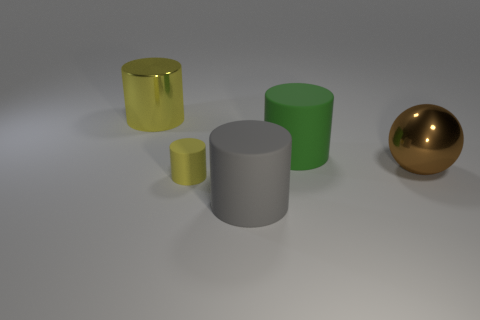There is a thing that is the same color as the metallic cylinder; what is its size?
Make the answer very short. Small. There is a yellow rubber thing that is the same shape as the big gray rubber thing; what size is it?
Your response must be concise. Small. Is there anything else that has the same size as the yellow matte object?
Make the answer very short. No. Are there more big rubber things that are in front of the green rubber cylinder than large gray things that are behind the big metal ball?
Provide a succinct answer. Yes. There is a thing that is behind the large green matte object; what is its material?
Ensure brevity in your answer.  Metal. There is a green object; is it the same shape as the large shiny object that is left of the gray thing?
Your response must be concise. Yes. There is a green thing that is behind the metallic object on the right side of the large shiny cylinder; how many small yellow objects are in front of it?
Offer a very short reply. 1. There is a big metal object that is the same shape as the large green matte object; what is its color?
Provide a succinct answer. Yellow. Is there any other thing that is the same shape as the brown shiny object?
Keep it short and to the point. No. How many spheres are rubber things or tiny yellow metallic objects?
Keep it short and to the point. 0. 